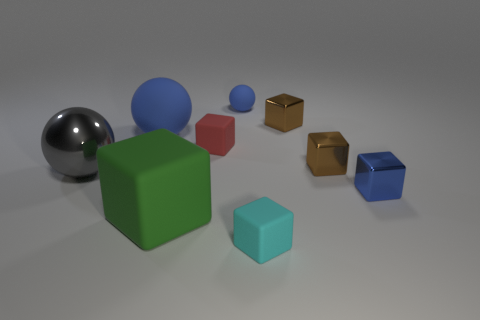If we consider these objects as part of a study, what could be the focus? Such an assemblage could partake in a study of lighting and shadows, material textures, or the spatial relationship between various geometric forms in a neutral setting. 